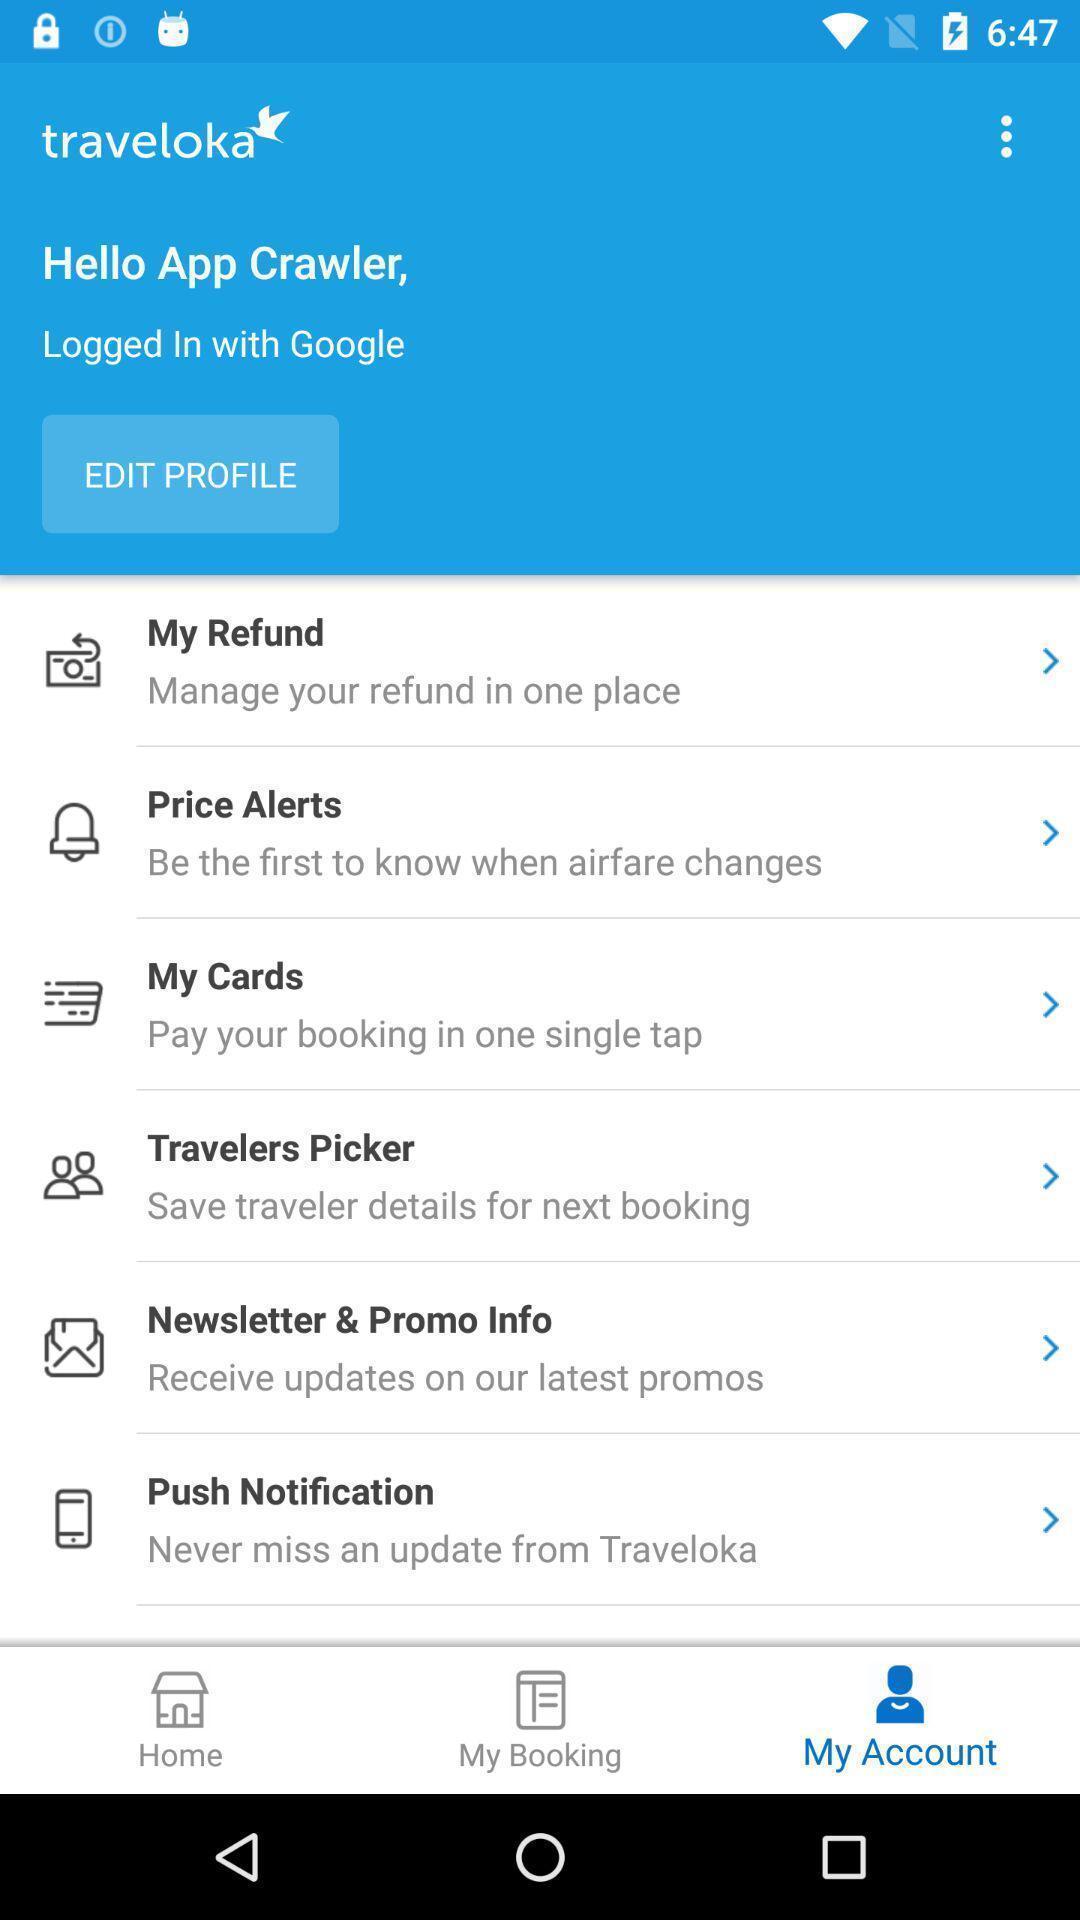Tell me what you see in this picture. Page displaying options in banking app. 